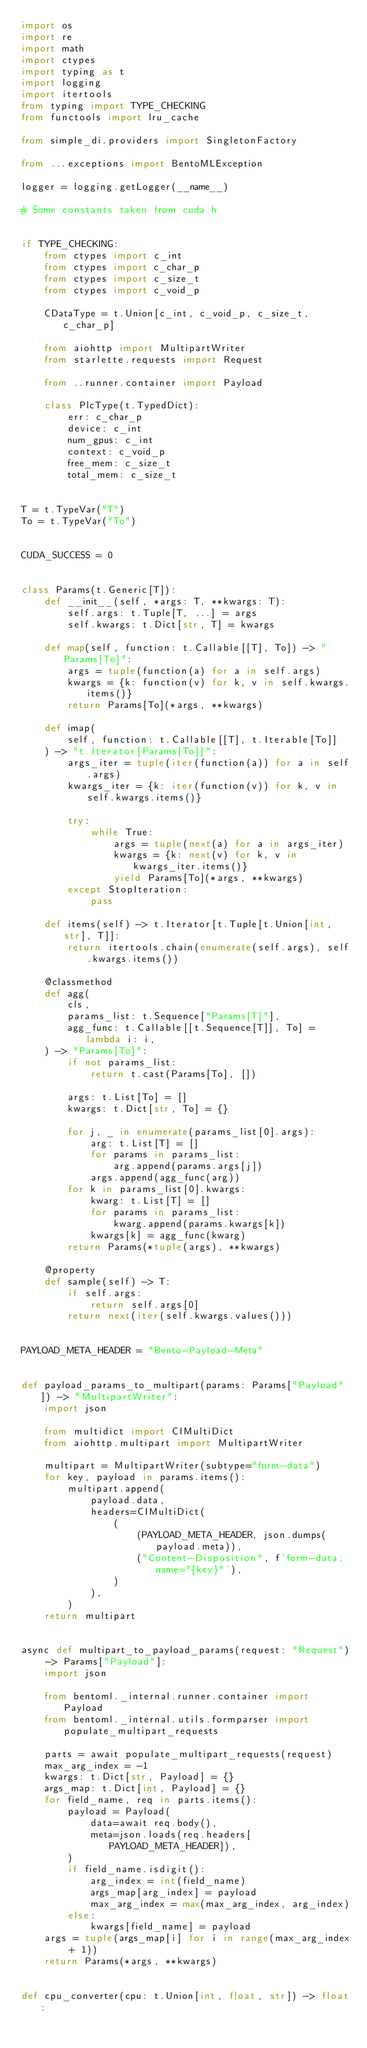Convert code to text. <code><loc_0><loc_0><loc_500><loc_500><_Python_>import os
import re
import math
import ctypes
import typing as t
import logging
import itertools
from typing import TYPE_CHECKING
from functools import lru_cache

from simple_di.providers import SingletonFactory

from ...exceptions import BentoMLException

logger = logging.getLogger(__name__)

# Some constants taken from cuda.h


if TYPE_CHECKING:
    from ctypes import c_int
    from ctypes import c_char_p
    from ctypes import c_size_t
    from ctypes import c_void_p

    CDataType = t.Union[c_int, c_void_p, c_size_t, c_char_p]

    from aiohttp import MultipartWriter
    from starlette.requests import Request

    from ..runner.container import Payload

    class PlcType(t.TypedDict):
        err: c_char_p
        device: c_int
        num_gpus: c_int
        context: c_void_p
        free_mem: c_size_t
        total_mem: c_size_t


T = t.TypeVar("T")
To = t.TypeVar("To")


CUDA_SUCCESS = 0


class Params(t.Generic[T]):
    def __init__(self, *args: T, **kwargs: T):
        self.args: t.Tuple[T, ...] = args
        self.kwargs: t.Dict[str, T] = kwargs

    def map(self, function: t.Callable[[T], To]) -> "Params[To]":
        args = tuple(function(a) for a in self.args)
        kwargs = {k: function(v) for k, v in self.kwargs.items()}
        return Params[To](*args, **kwargs)

    def imap(
        self, function: t.Callable[[T], t.Iterable[To]]
    ) -> "t.Iterator[Params[To]]":
        args_iter = tuple(iter(function(a)) for a in self.args)
        kwargs_iter = {k: iter(function(v)) for k, v in self.kwargs.items()}

        try:
            while True:
                args = tuple(next(a) for a in args_iter)
                kwargs = {k: next(v) for k, v in kwargs_iter.items()}
                yield Params[To](*args, **kwargs)
        except StopIteration:
            pass

    def items(self) -> t.Iterator[t.Tuple[t.Union[int, str], T]]:
        return itertools.chain(enumerate(self.args), self.kwargs.items())

    @classmethod
    def agg(
        cls,
        params_list: t.Sequence["Params[T]"],
        agg_func: t.Callable[[t.Sequence[T]], To] = lambda i: i,
    ) -> "Params[To]":
        if not params_list:
            return t.cast(Params[To], [])

        args: t.List[To] = []
        kwargs: t.Dict[str, To] = {}

        for j, _ in enumerate(params_list[0].args):
            arg: t.List[T] = []
            for params in params_list:
                arg.append(params.args[j])
            args.append(agg_func(arg))
        for k in params_list[0].kwargs:
            kwarg: t.List[T] = []
            for params in params_list:
                kwarg.append(params.kwargs[k])
            kwargs[k] = agg_func(kwarg)
        return Params(*tuple(args), **kwargs)

    @property
    def sample(self) -> T:
        if self.args:
            return self.args[0]
        return next(iter(self.kwargs.values()))


PAYLOAD_META_HEADER = "Bento-Payload-Meta"


def payload_params_to_multipart(params: Params["Payload"]) -> "MultipartWriter":
    import json

    from multidict import CIMultiDict
    from aiohttp.multipart import MultipartWriter

    multipart = MultipartWriter(subtype="form-data")
    for key, payload in params.items():
        multipart.append(
            payload.data,
            headers=CIMultiDict(
                (
                    (PAYLOAD_META_HEADER, json.dumps(payload.meta)),
                    ("Content-Disposition", f'form-data; name="{key}"'),
                )
            ),
        )
    return multipart


async def multipart_to_payload_params(request: "Request") -> Params["Payload"]:
    import json

    from bentoml._internal.runner.container import Payload
    from bentoml._internal.utils.formparser import populate_multipart_requests

    parts = await populate_multipart_requests(request)
    max_arg_index = -1
    kwargs: t.Dict[str, Payload] = {}
    args_map: t.Dict[int, Payload] = {}
    for field_name, req in parts.items():
        payload = Payload(
            data=await req.body(),
            meta=json.loads(req.headers[PAYLOAD_META_HEADER]),
        )
        if field_name.isdigit():
            arg_index = int(field_name)
            args_map[arg_index] = payload
            max_arg_index = max(max_arg_index, arg_index)
        else:
            kwargs[field_name] = payload
    args = tuple(args_map[i] for i in range(max_arg_index + 1))
    return Params(*args, **kwargs)


def cpu_converter(cpu: t.Union[int, float, str]) -> float:</code> 